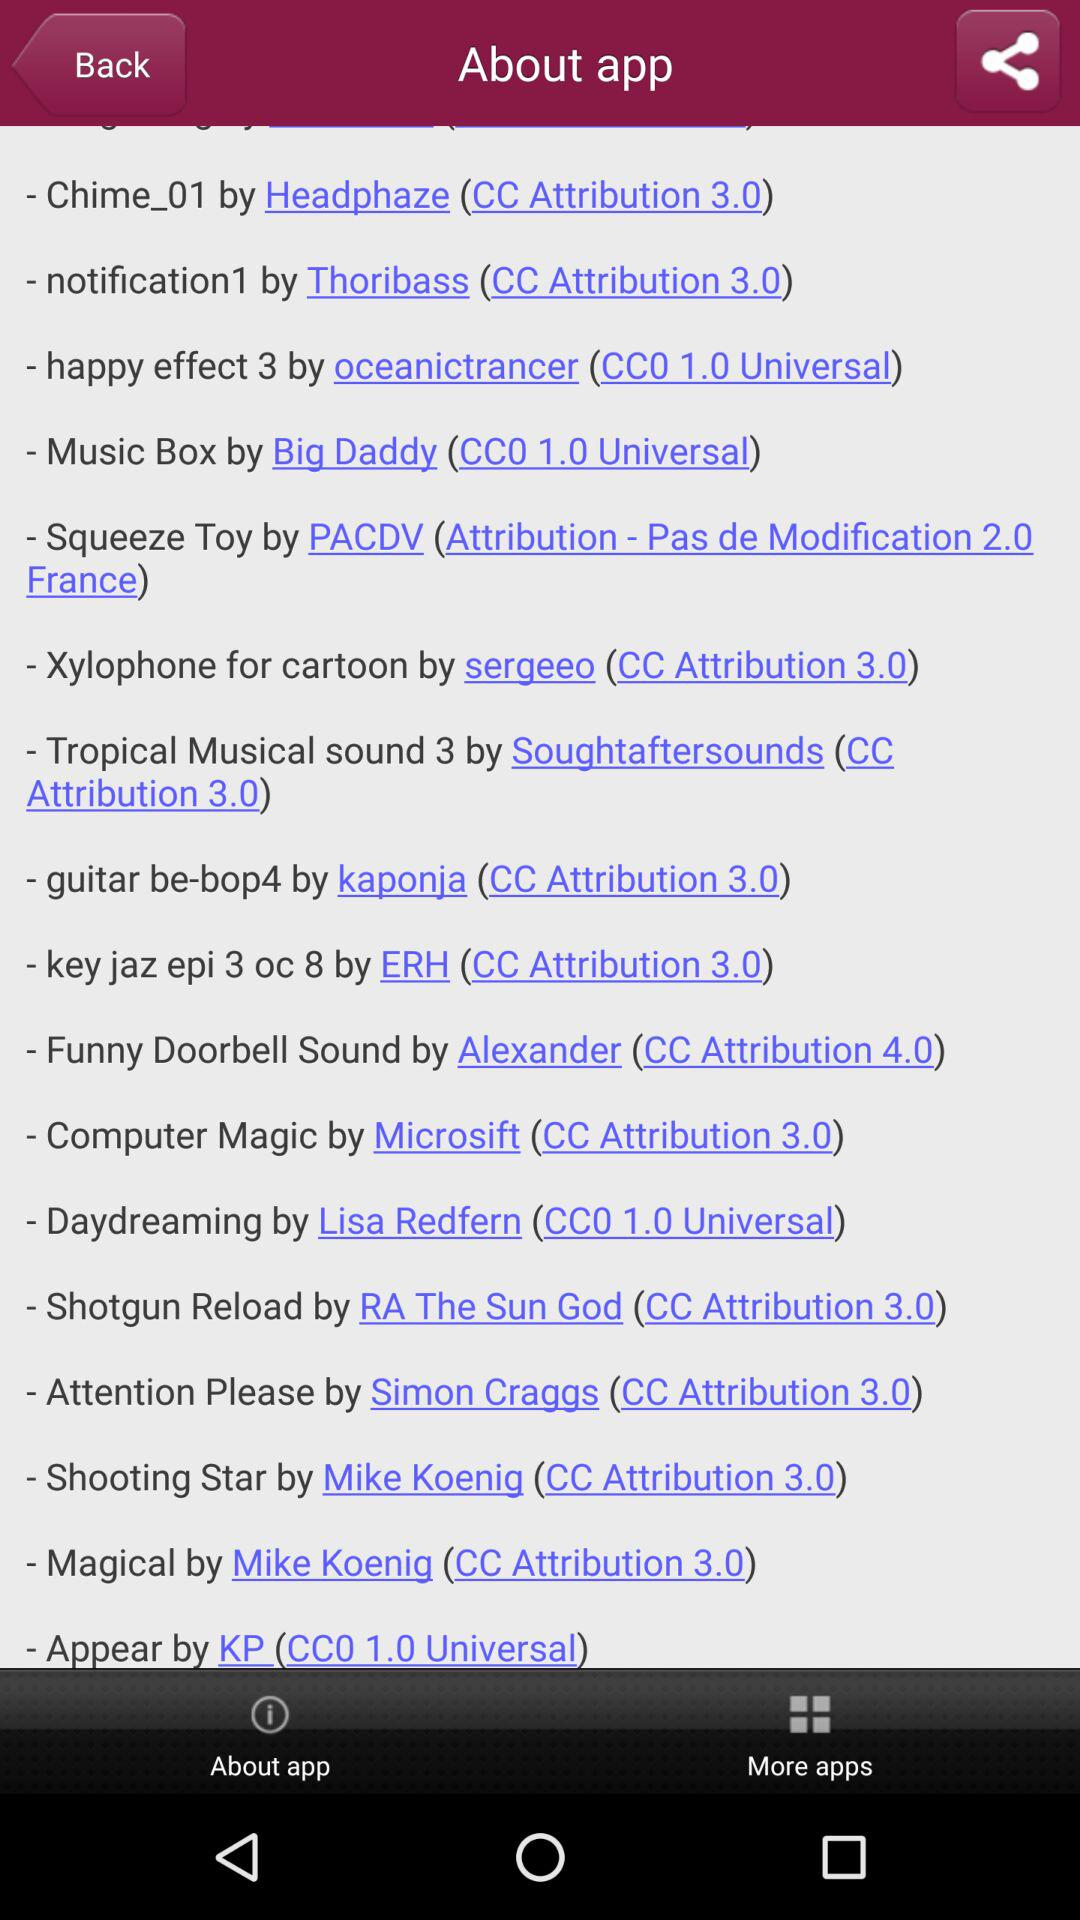Who developed "Music Box"? It is developed by Big Daddy. 